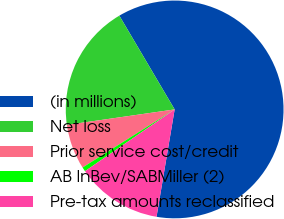Convert chart. <chart><loc_0><loc_0><loc_500><loc_500><pie_chart><fcel>(in millions)<fcel>Net loss<fcel>Prior service cost/credit<fcel>AB InBev/SABMiller (2)<fcel>Pre-tax amounts reclassified<nl><fcel>61.15%<fcel>18.79%<fcel>6.69%<fcel>0.64%<fcel>12.74%<nl></chart> 